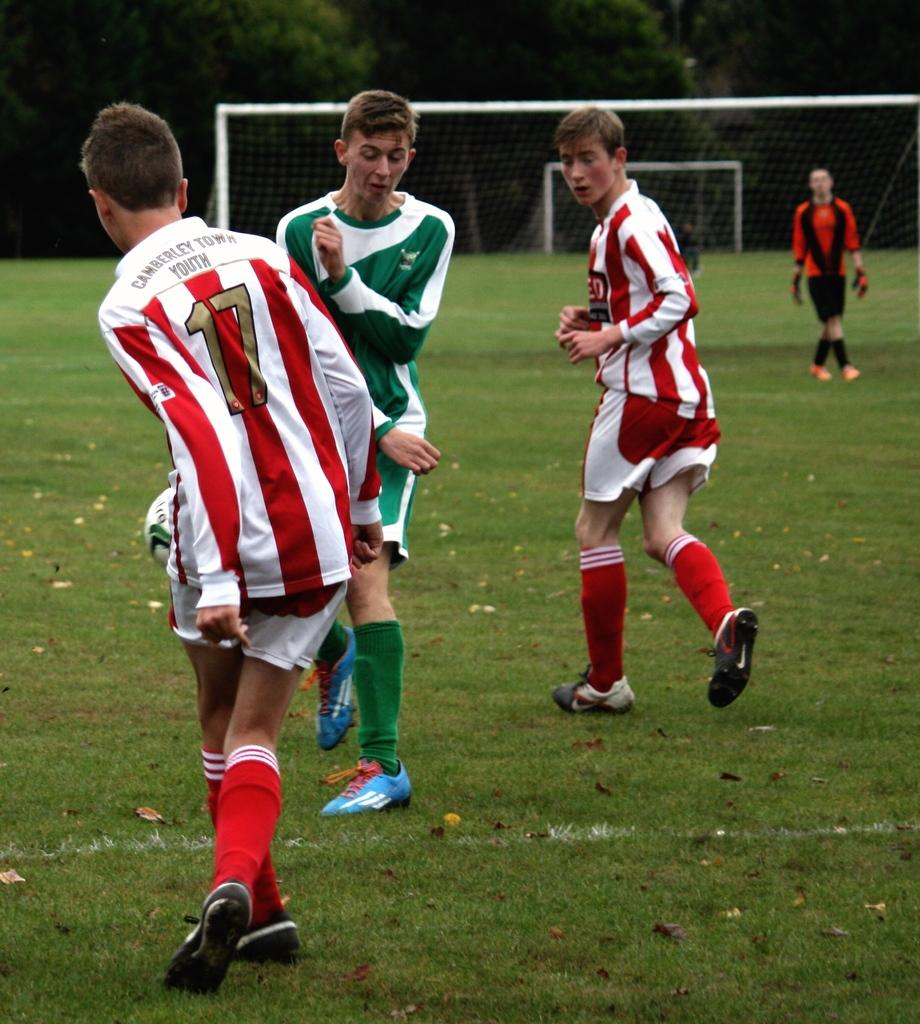What sport are the players engaged in within the image? The players are playing football in the image. Where is the football game taking place? The football game is taking place on a ground. What can be found on the ground in the image? There are leaves and grass on the ground. What structures are present in the background of the image? There are two nets and trees visible in the background. What type of books can be seen in the library in the image? There is no library present in the image; it features a football game taking place on a ground. Can you tell me how many men are playing football in the image? The question does not specify which men are being referred to, as there are no individual men mentioned in the provided facts. 